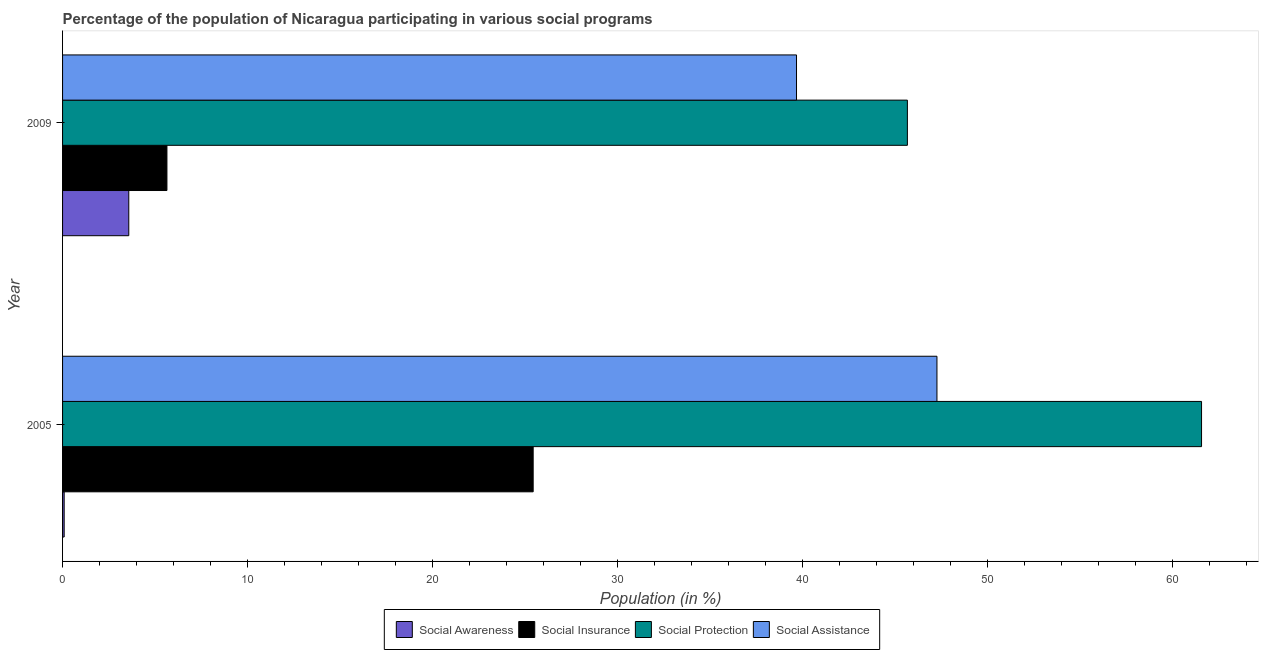How many groups of bars are there?
Provide a succinct answer. 2. Are the number of bars per tick equal to the number of legend labels?
Ensure brevity in your answer.  Yes. Are the number of bars on each tick of the Y-axis equal?
Your answer should be compact. Yes. In how many cases, is the number of bars for a given year not equal to the number of legend labels?
Keep it short and to the point. 0. What is the participation of population in social awareness programs in 2009?
Give a very brief answer. 3.58. Across all years, what is the maximum participation of population in social awareness programs?
Offer a terse response. 3.58. Across all years, what is the minimum participation of population in social protection programs?
Your answer should be compact. 45.65. In which year was the participation of population in social awareness programs maximum?
Provide a succinct answer. 2009. In which year was the participation of population in social insurance programs minimum?
Offer a very short reply. 2009. What is the total participation of population in social awareness programs in the graph?
Your answer should be very brief. 3.66. What is the difference between the participation of population in social insurance programs in 2005 and that in 2009?
Provide a short and direct response. 19.79. What is the difference between the participation of population in social awareness programs in 2009 and the participation of population in social assistance programs in 2005?
Ensure brevity in your answer.  -43.67. What is the average participation of population in social awareness programs per year?
Your response must be concise. 1.83. In the year 2009, what is the difference between the participation of population in social assistance programs and participation of population in social insurance programs?
Provide a succinct answer. 34.02. What is the ratio of the participation of population in social insurance programs in 2005 to that in 2009?
Your answer should be compact. 4.51. What does the 4th bar from the top in 2009 represents?
Your answer should be compact. Social Awareness. What does the 1st bar from the bottom in 2009 represents?
Make the answer very short. Social Awareness. Is it the case that in every year, the sum of the participation of population in social awareness programs and participation of population in social insurance programs is greater than the participation of population in social protection programs?
Keep it short and to the point. No. Are the values on the major ticks of X-axis written in scientific E-notation?
Your response must be concise. No. Does the graph contain any zero values?
Offer a terse response. No. Does the graph contain grids?
Give a very brief answer. No. Where does the legend appear in the graph?
Make the answer very short. Bottom center. How many legend labels are there?
Your response must be concise. 4. How are the legend labels stacked?
Your answer should be compact. Horizontal. What is the title of the graph?
Offer a very short reply. Percentage of the population of Nicaragua participating in various social programs . What is the label or title of the X-axis?
Give a very brief answer. Population (in %). What is the label or title of the Y-axis?
Provide a short and direct response. Year. What is the Population (in %) of Social Awareness in 2005?
Your answer should be very brief. 0.09. What is the Population (in %) in Social Insurance in 2005?
Ensure brevity in your answer.  25.43. What is the Population (in %) of Social Protection in 2005?
Offer a terse response. 61.55. What is the Population (in %) in Social Assistance in 2005?
Keep it short and to the point. 47.25. What is the Population (in %) in Social Awareness in 2009?
Give a very brief answer. 3.58. What is the Population (in %) in Social Insurance in 2009?
Keep it short and to the point. 5.64. What is the Population (in %) in Social Protection in 2009?
Give a very brief answer. 45.65. What is the Population (in %) of Social Assistance in 2009?
Your answer should be compact. 39.66. Across all years, what is the maximum Population (in %) of Social Awareness?
Your response must be concise. 3.58. Across all years, what is the maximum Population (in %) in Social Insurance?
Your answer should be very brief. 25.43. Across all years, what is the maximum Population (in %) of Social Protection?
Provide a succinct answer. 61.55. Across all years, what is the maximum Population (in %) of Social Assistance?
Your response must be concise. 47.25. Across all years, what is the minimum Population (in %) in Social Awareness?
Your response must be concise. 0.09. Across all years, what is the minimum Population (in %) of Social Insurance?
Your response must be concise. 5.64. Across all years, what is the minimum Population (in %) of Social Protection?
Your answer should be very brief. 45.65. Across all years, what is the minimum Population (in %) in Social Assistance?
Give a very brief answer. 39.66. What is the total Population (in %) of Social Awareness in the graph?
Keep it short and to the point. 3.67. What is the total Population (in %) of Social Insurance in the graph?
Provide a succinct answer. 31.07. What is the total Population (in %) in Social Protection in the graph?
Your answer should be very brief. 107.2. What is the total Population (in %) of Social Assistance in the graph?
Offer a very short reply. 86.91. What is the difference between the Population (in %) of Social Awareness in 2005 and that in 2009?
Offer a terse response. -3.49. What is the difference between the Population (in %) in Social Insurance in 2005 and that in 2009?
Your answer should be very brief. 19.79. What is the difference between the Population (in %) in Social Protection in 2005 and that in 2009?
Ensure brevity in your answer.  15.89. What is the difference between the Population (in %) of Social Assistance in 2005 and that in 2009?
Your answer should be very brief. 7.59. What is the difference between the Population (in %) of Social Awareness in 2005 and the Population (in %) of Social Insurance in 2009?
Provide a succinct answer. -5.55. What is the difference between the Population (in %) in Social Awareness in 2005 and the Population (in %) in Social Protection in 2009?
Ensure brevity in your answer.  -45.56. What is the difference between the Population (in %) of Social Awareness in 2005 and the Population (in %) of Social Assistance in 2009?
Your answer should be compact. -39.57. What is the difference between the Population (in %) of Social Insurance in 2005 and the Population (in %) of Social Protection in 2009?
Offer a terse response. -20.22. What is the difference between the Population (in %) of Social Insurance in 2005 and the Population (in %) of Social Assistance in 2009?
Your answer should be compact. -14.23. What is the difference between the Population (in %) of Social Protection in 2005 and the Population (in %) of Social Assistance in 2009?
Provide a short and direct response. 21.89. What is the average Population (in %) of Social Awareness per year?
Your answer should be compact. 1.83. What is the average Population (in %) of Social Insurance per year?
Make the answer very short. 15.53. What is the average Population (in %) of Social Protection per year?
Provide a succinct answer. 53.6. What is the average Population (in %) in Social Assistance per year?
Offer a terse response. 43.45. In the year 2005, what is the difference between the Population (in %) in Social Awareness and Population (in %) in Social Insurance?
Offer a very short reply. -25.34. In the year 2005, what is the difference between the Population (in %) in Social Awareness and Population (in %) in Social Protection?
Keep it short and to the point. -61.46. In the year 2005, what is the difference between the Population (in %) of Social Awareness and Population (in %) of Social Assistance?
Offer a terse response. -47.16. In the year 2005, what is the difference between the Population (in %) in Social Insurance and Population (in %) in Social Protection?
Your answer should be compact. -36.12. In the year 2005, what is the difference between the Population (in %) of Social Insurance and Population (in %) of Social Assistance?
Provide a short and direct response. -21.82. In the year 2005, what is the difference between the Population (in %) in Social Protection and Population (in %) in Social Assistance?
Your answer should be very brief. 14.3. In the year 2009, what is the difference between the Population (in %) of Social Awareness and Population (in %) of Social Insurance?
Give a very brief answer. -2.06. In the year 2009, what is the difference between the Population (in %) of Social Awareness and Population (in %) of Social Protection?
Ensure brevity in your answer.  -42.07. In the year 2009, what is the difference between the Population (in %) in Social Awareness and Population (in %) in Social Assistance?
Provide a short and direct response. -36.08. In the year 2009, what is the difference between the Population (in %) in Social Insurance and Population (in %) in Social Protection?
Provide a succinct answer. -40.01. In the year 2009, what is the difference between the Population (in %) in Social Insurance and Population (in %) in Social Assistance?
Your response must be concise. -34.02. In the year 2009, what is the difference between the Population (in %) of Social Protection and Population (in %) of Social Assistance?
Your answer should be compact. 5.99. What is the ratio of the Population (in %) of Social Awareness in 2005 to that in 2009?
Provide a succinct answer. 0.02. What is the ratio of the Population (in %) in Social Insurance in 2005 to that in 2009?
Your answer should be compact. 4.51. What is the ratio of the Population (in %) in Social Protection in 2005 to that in 2009?
Your response must be concise. 1.35. What is the ratio of the Population (in %) of Social Assistance in 2005 to that in 2009?
Give a very brief answer. 1.19. What is the difference between the highest and the second highest Population (in %) in Social Awareness?
Your response must be concise. 3.49. What is the difference between the highest and the second highest Population (in %) in Social Insurance?
Give a very brief answer. 19.79. What is the difference between the highest and the second highest Population (in %) of Social Protection?
Your response must be concise. 15.89. What is the difference between the highest and the second highest Population (in %) of Social Assistance?
Give a very brief answer. 7.59. What is the difference between the highest and the lowest Population (in %) in Social Awareness?
Give a very brief answer. 3.49. What is the difference between the highest and the lowest Population (in %) of Social Insurance?
Your answer should be compact. 19.79. What is the difference between the highest and the lowest Population (in %) in Social Protection?
Provide a short and direct response. 15.89. What is the difference between the highest and the lowest Population (in %) in Social Assistance?
Keep it short and to the point. 7.59. 